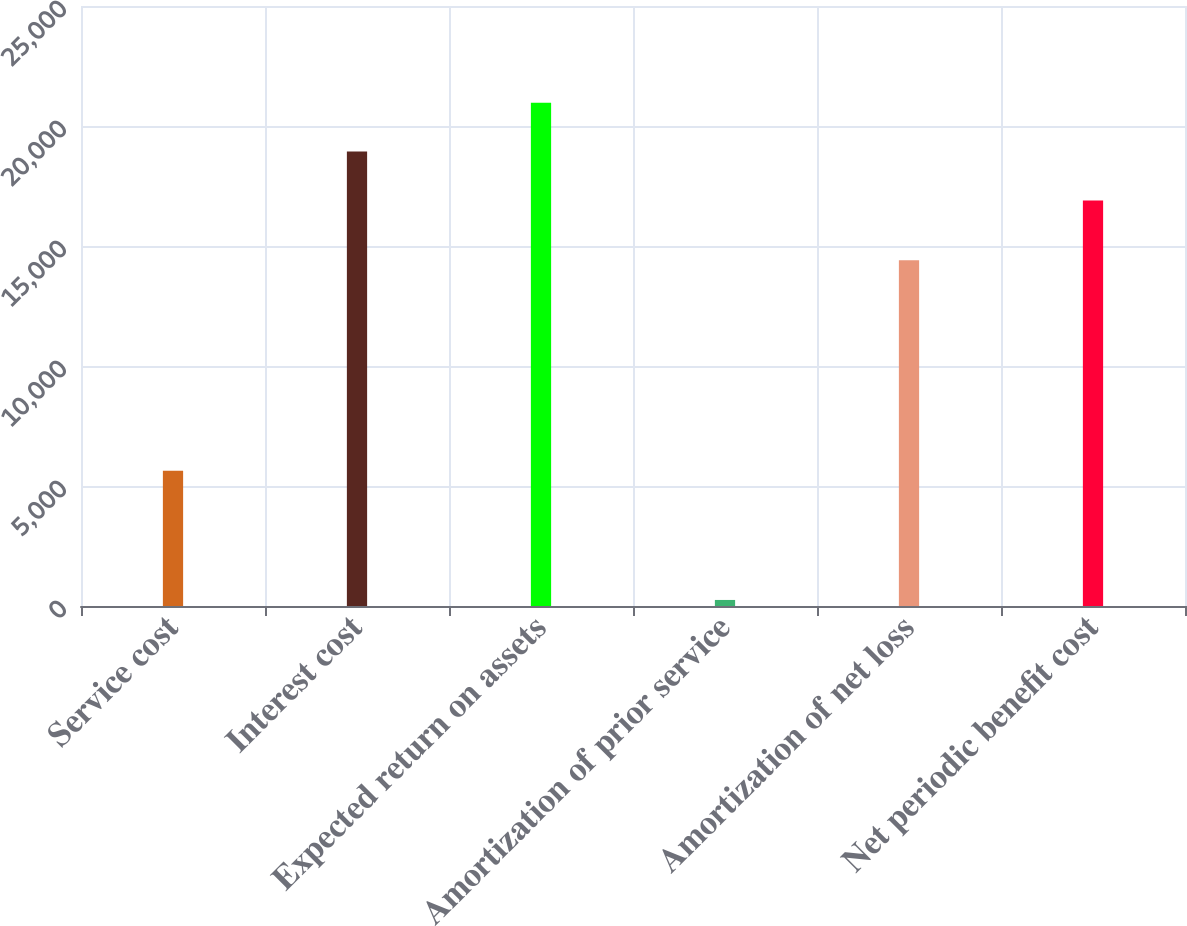Convert chart to OTSL. <chart><loc_0><loc_0><loc_500><loc_500><bar_chart><fcel>Service cost<fcel>Interest cost<fcel>Expected return on assets<fcel>Amortization of prior service<fcel>Amortization of net loss<fcel>Net periodic benefit cost<nl><fcel>5633<fcel>18932.3<fcel>20966.6<fcel>252<fcel>14403<fcel>16898<nl></chart> 